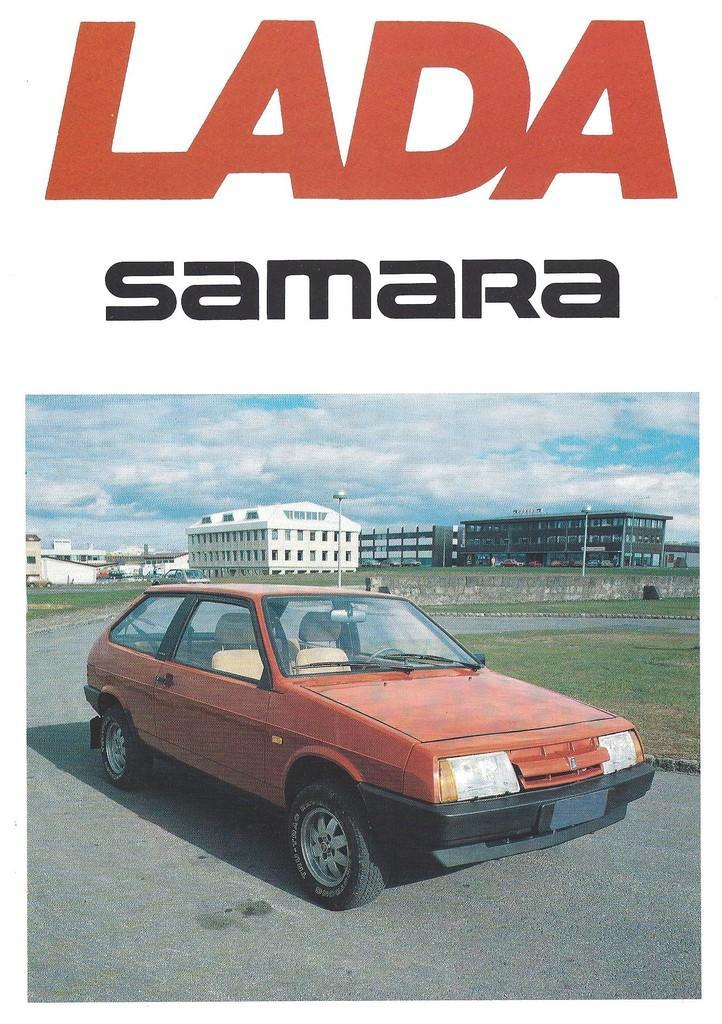Could you give a brief overview of what you see in this image? This is an advertisement. In the center of the image we can see a car. In the background of the image we can see the buildings, poles, wall, grass. At the bottom of the image we can see the road. At the top of the image we can see the clouds are present in the sky and we can see some text. 